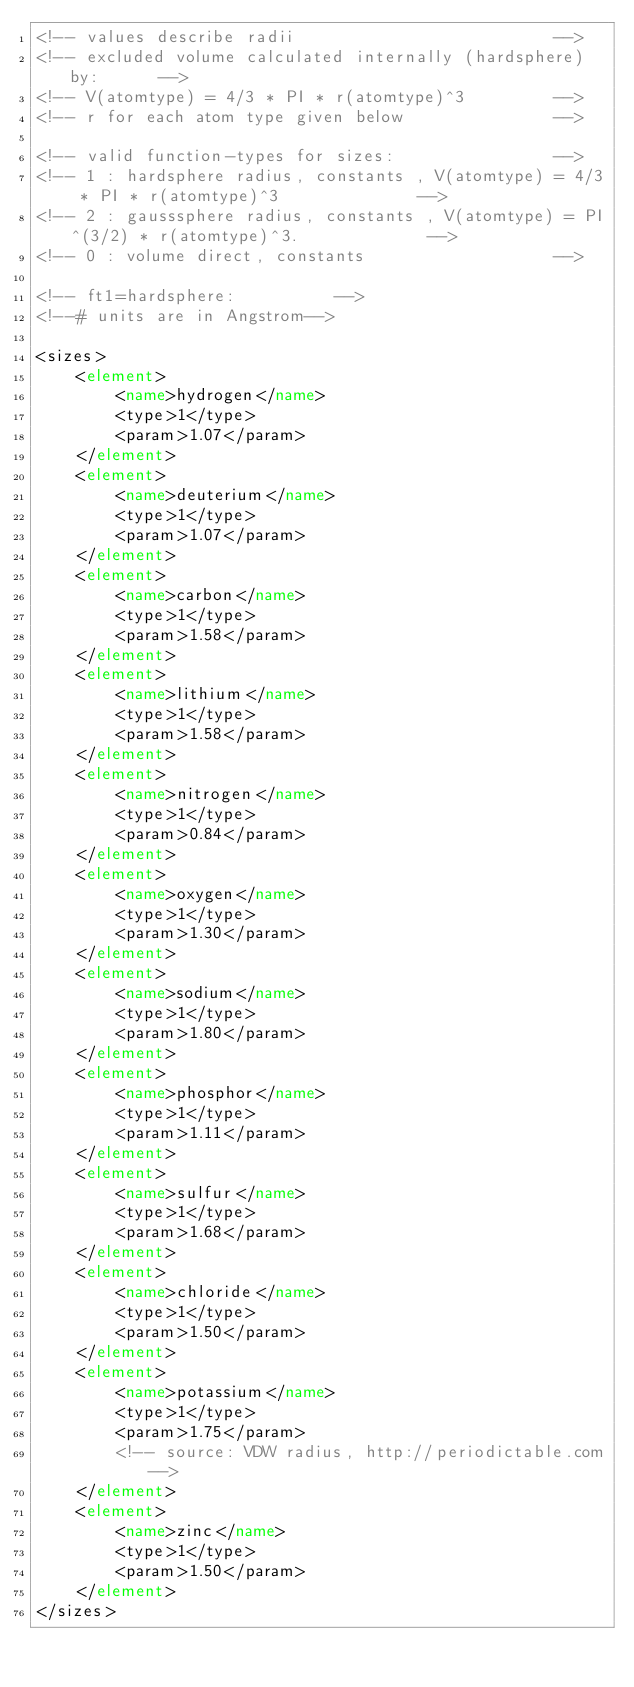<code> <loc_0><loc_0><loc_500><loc_500><_XML_><!-- values describe radii                          -->
<!-- excluded volume calculated internally (hardsphere) by:      -->
<!-- V(atomtype) = 4/3 * PI * r(atomtype)^3         -->
<!-- r for each atom type given below               -->

<!-- valid function-types for sizes:                -->
<!-- 1 : hardsphere radius, constants , V(atomtype) = 4/3 * PI * r(atomtype)^3              -->
<!-- 2 : gausssphere radius, constants , V(atomtype) = PI^(3/2) * r(atomtype)^3.             -->
<!-- 0 : volume direct, constants                   -->

<!-- ft1=hardsphere:          -->
<!--# units are in Angstrom-->

<sizes>
	<element>
		<name>hydrogen</name>
		<type>1</type>
		<param>1.07</param>
	</element>
	<element>
		<name>deuterium</name>
		<type>1</type>
		<param>1.07</param>
	</element>
	<element>
		<name>carbon</name>
		<type>1</type>
		<param>1.58</param>
	</element>
	<element>
		<name>lithium</name>
		<type>1</type>
		<param>1.58</param>
	</element>
	<element>
		<name>nitrogen</name>
		<type>1</type>
		<param>0.84</param>
	</element>
	<element>
		<name>oxygen</name>
		<type>1</type>
		<param>1.30</param>
	</element>
	<element>
		<name>sodium</name>
		<type>1</type>
		<param>1.80</param>
	</element>
	<element>
		<name>phosphor</name>
		<type>1</type>
		<param>1.11</param>
	</element>
	<element>
		<name>sulfur</name>
		<type>1</type>
		<param>1.68</param>
	</element>
	<element>
		<name>chloride</name>
		<type>1</type>
		<param>1.50</param>
	</element>
	<element>
		<name>potassium</name>
		<type>1</type>
		<param>1.75</param>
		<!-- source: VDW radius, http://periodictable.com-->
	</element>
	<element>
		<name>zinc</name>
		<type>1</type>
		<param>1.50</param>
	</element>
</sizes></code> 